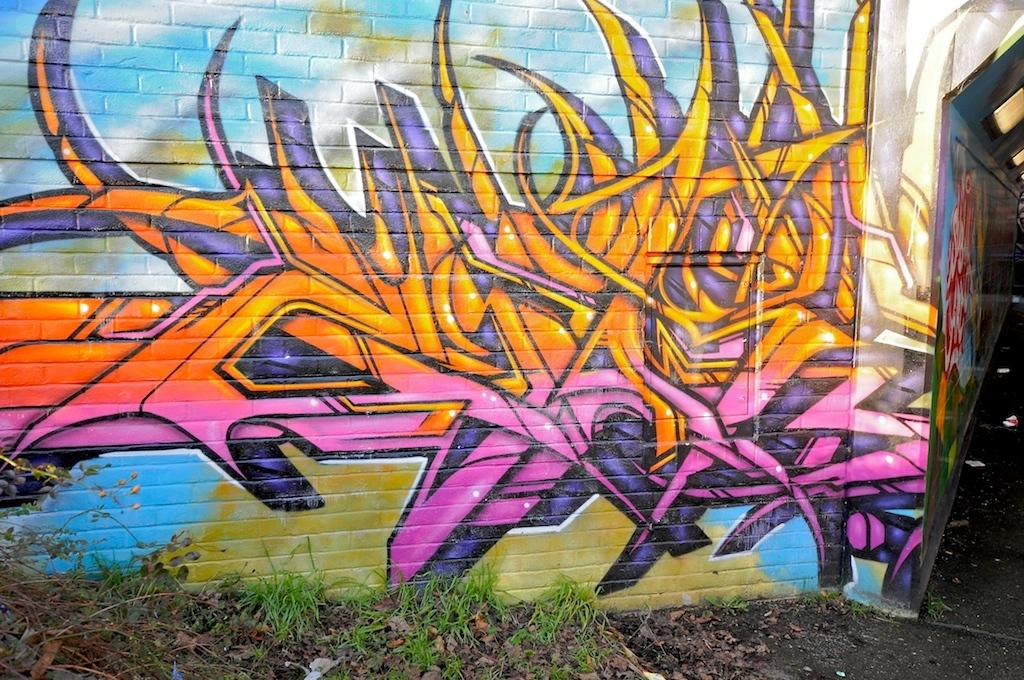What can be seen on the wall in the background of the image? There is a wall with graffiti in the background of the image. What is located at the bottom of the image? Dry leaves and plants are present at the bottom of the image. What type of cast can be seen on the plants in the image? There is no cast present on the plants in the image. How do the dry leaves move in the image? The dry leaves do not move in the image; they are stationary at the bottom. 